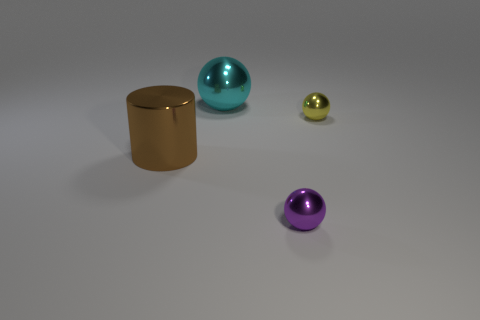Are there any big cyan balls that are behind the object left of the large cyan ball?
Provide a succinct answer. Yes. Do the tiny purple shiny thing and the large brown object have the same shape?
Offer a very short reply. No. What is the color of the thing that is left of the shiny sphere that is left of the sphere in front of the big brown metallic cylinder?
Provide a short and direct response. Brown. How many other tiny things are the same shape as the cyan shiny object?
Give a very brief answer. 2. How big is the ball that is left of the purple metal ball to the right of the large cyan metal thing?
Keep it short and to the point. Large. Is the size of the yellow metal thing the same as the cyan shiny object?
Make the answer very short. No. Is there a big cyan shiny sphere that is on the right side of the metal object to the right of the tiny ball in front of the big shiny cylinder?
Give a very brief answer. No. How big is the cyan ball?
Offer a terse response. Large. How many shiny things are the same size as the cyan ball?
Make the answer very short. 1. There is a thing that is in front of the small yellow sphere and to the right of the big metal cylinder; what is its shape?
Give a very brief answer. Sphere. 